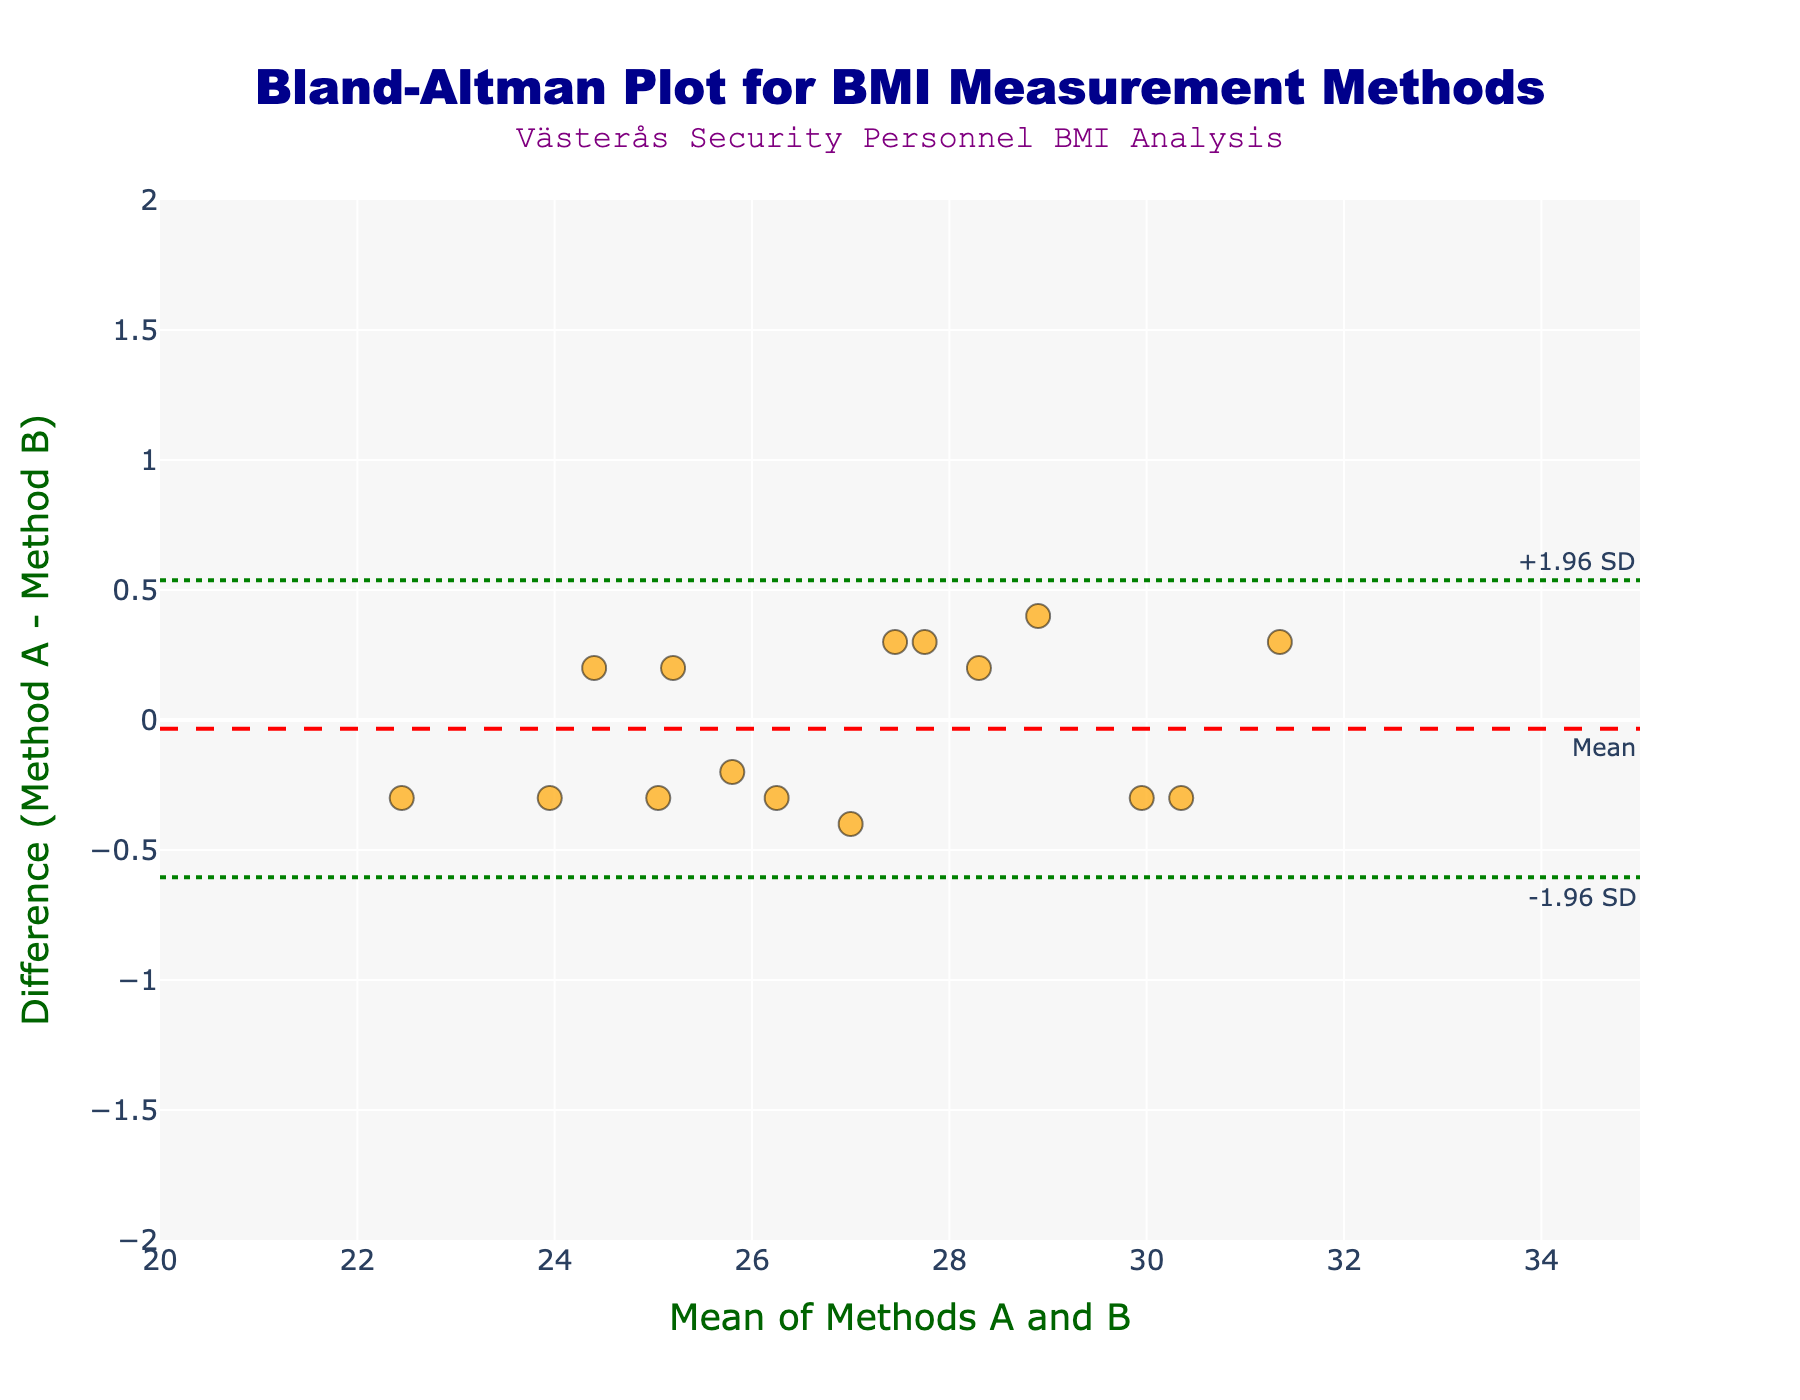What is the title of the plot? The title is usually at the top of the figure. Here, it is "Bland-Altman Plot for BMI Measurement Methods".
Answer: Bland-Altman Plot for BMI Measurement Methods What is the color of the data points in the scatter plot? The data points are visually identifiable in the figure; they are colored in an orange shade with a semi-transparent appearance.
Answer: Orange What are the x-axis and y-axis titles? The x-axis and y-axis titles are displayed near the respective axes. The x-axis title is "Mean of Methods A and B" and the y-axis title is "Difference (Method A - Method B)".
Answer: Mean of Methods A and B, Difference (Method A - Method B) What is the range of the mean differences in the y-axis? The range can be observed by looking at the axis labels. For the y-axis, it goes from -2 to 2.
Answer: -2 to 2 How many data points are plotted in the Bland-Altman plot? By counting the number of markers shown in the scatter plot, we can determine the number of data points. There are 15 data points.
Answer: 15 What is the annotated text in the top left corner of the plot? Annotations are visible texts added for additional information. In this plot, an annotation reads "Västerås Security Personnel BMI Analysis" in the top left corner.
Answer: Västerås Security Personnel BMI Analysis What color and style are the lines that represent the ±1.96 SD? These lines are visible and distinguished by color and style in the figure. They are green and have a dotted style.
Answer: Green, dotted What's the mean difference between Method A and Method B? The mean difference is represented by the red dashed line and noted by an annotation. The y-axis annotation at this line reads "Mean".
Answer: Approximately 0 (since it's not explicitly given, and no significant deviation is shown from 0 on the y-axis) What is the approximate value of the upper limit of agreement (+1.96 SD)? The upper limit of agreement line is annotated as "+1.96 SD" and can be observed at approximately 1.5 on the y-axis.
Answer: Approximately 1.5 Do most data points fall within the limits of agreement? By observing the scatter plot, most data points fall between the upper and lower limits of agreement (green dotted lines), indicating that most data points are within these limits.
Answer: Yes 